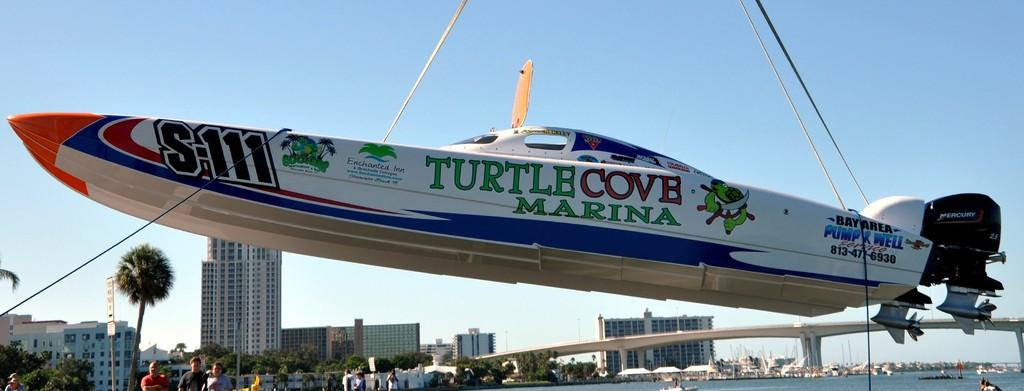<image>
Give a short and clear explanation of the subsequent image. a plane that has the word turtle on it 